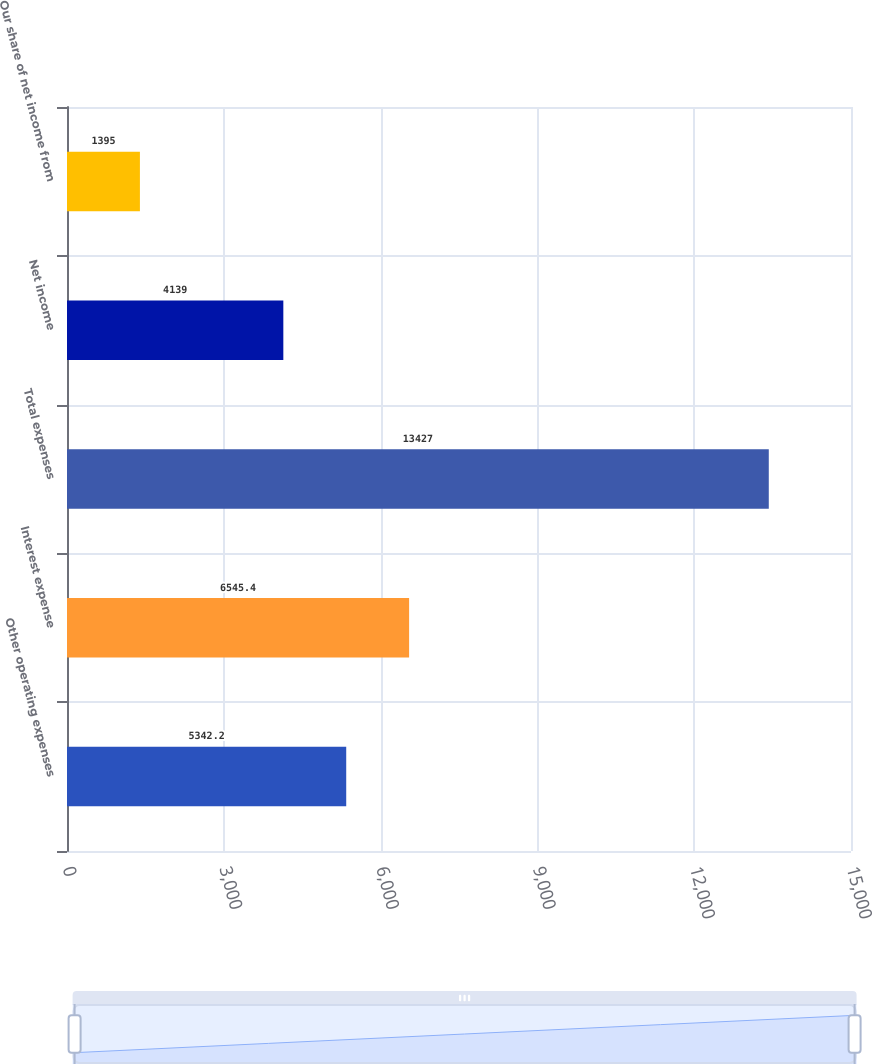Convert chart to OTSL. <chart><loc_0><loc_0><loc_500><loc_500><bar_chart><fcel>Other operating expenses<fcel>Interest expense<fcel>Total expenses<fcel>Net income<fcel>Our share of net income from<nl><fcel>5342.2<fcel>6545.4<fcel>13427<fcel>4139<fcel>1395<nl></chart> 